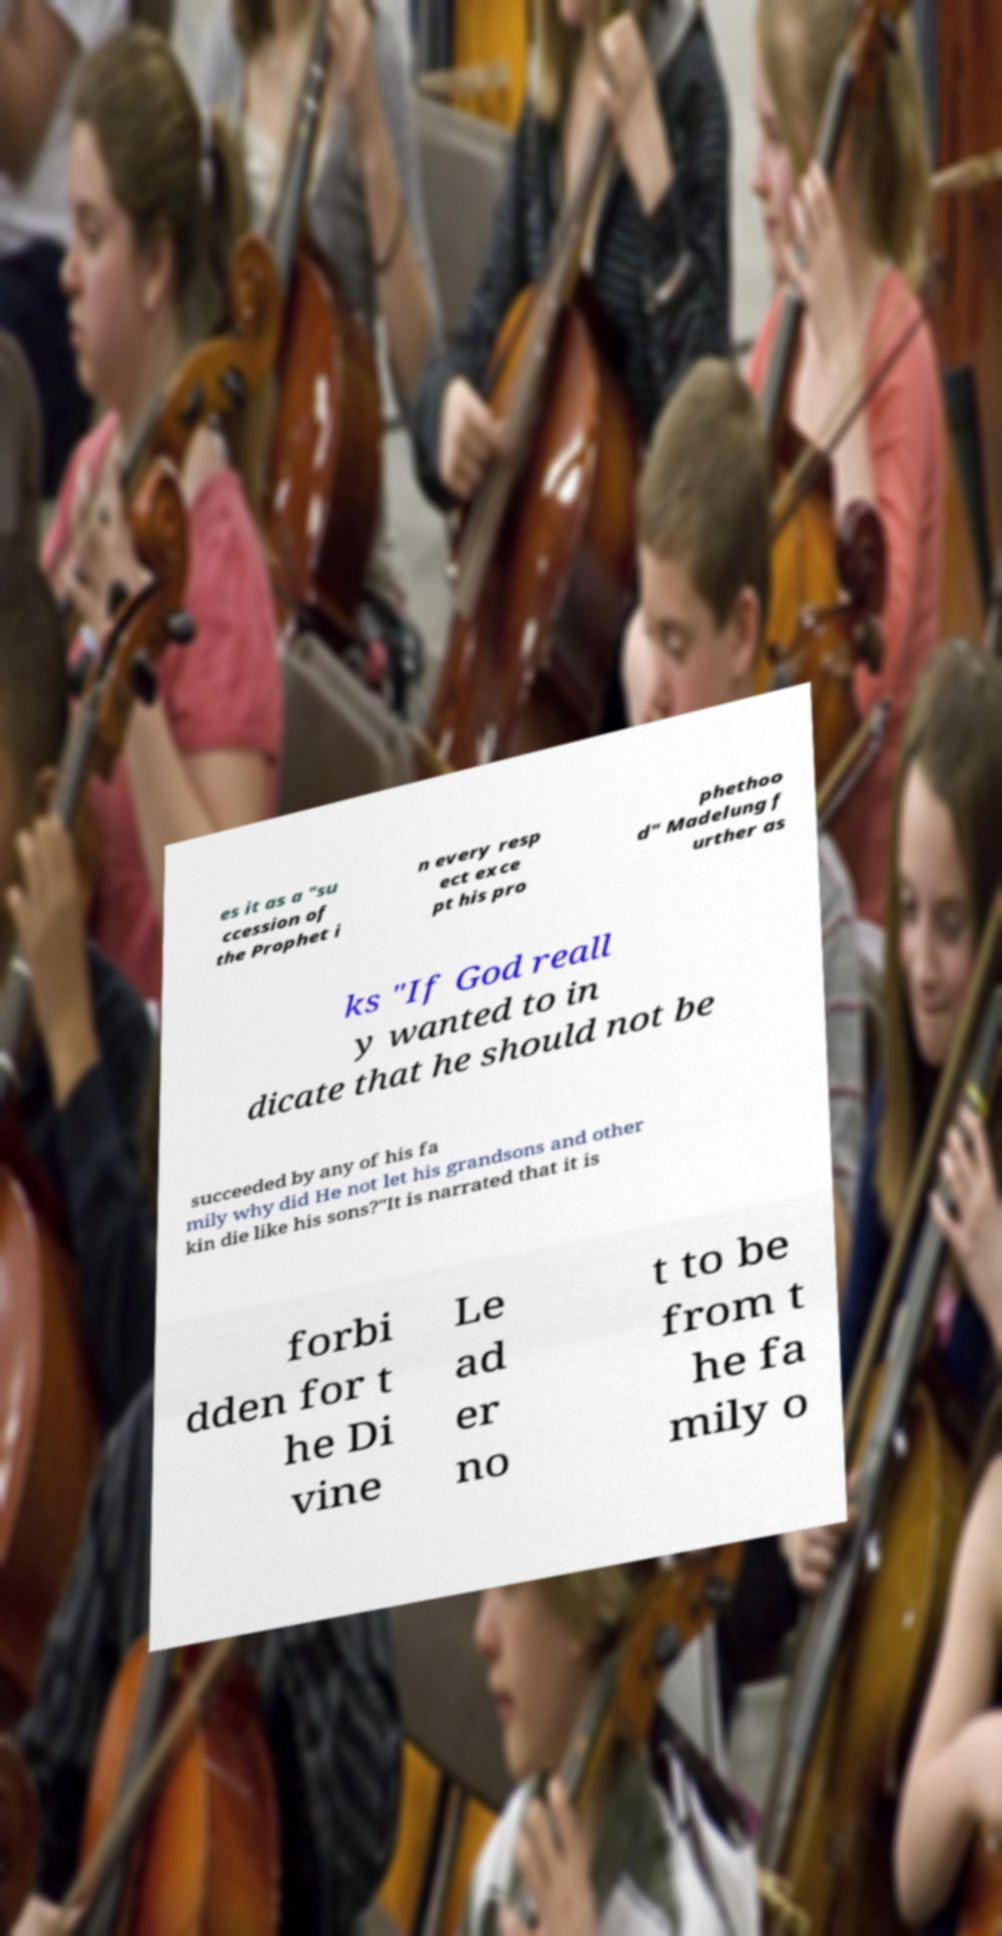Can you accurately transcribe the text from the provided image for me? es it as a "su ccession of the Prophet i n every resp ect exce pt his pro phethoo d" Madelung f urther as ks "If God reall y wanted to in dicate that he should not be succeeded by any of his fa mily why did He not let his grandsons and other kin die like his sons?"It is narrated that it is forbi dden for t he Di vine Le ad er no t to be from t he fa mily o 